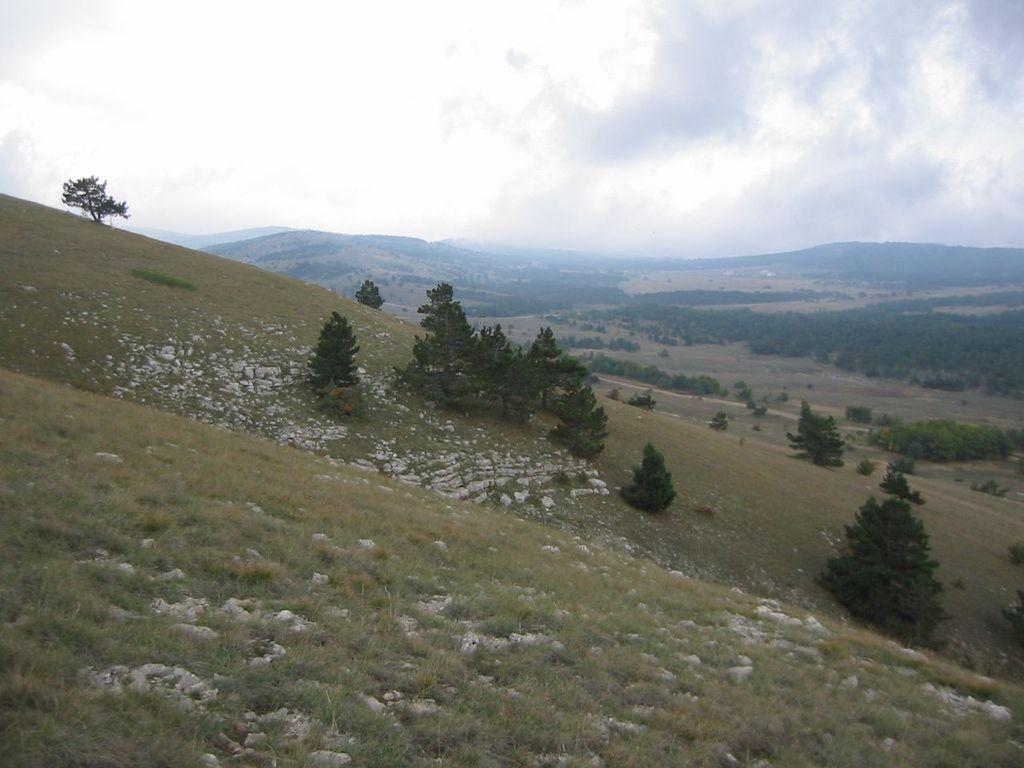What type of landscape feature can be seen in the image? There are hills in the image. What other natural elements are present in the image? There is a group of trees in the image. What is visible at the top of the image? The sky is visible at the top of the image. What side of the hill is the back of the tree facing? There is no indication of the back of the tree or which side it is facing in the image. 